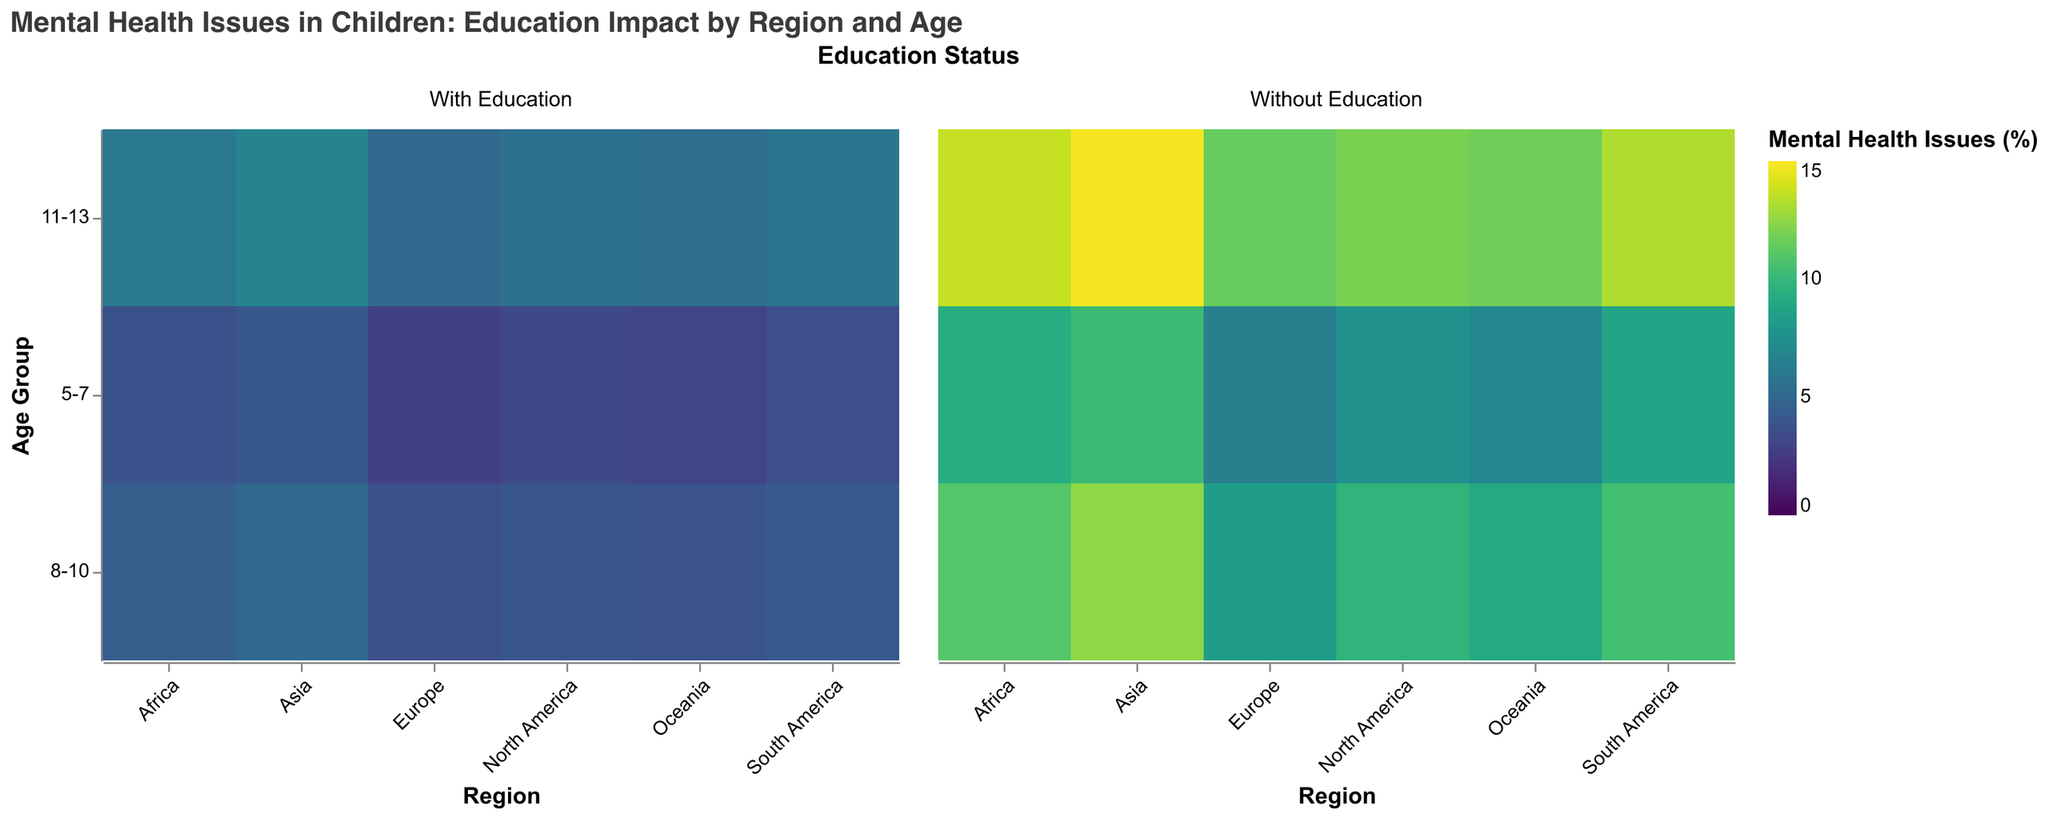What is the title of the heatmap? The title of the heatmap is specified at the top of the figure.
Answer: Mental Health Issues in Children: Education Impact by Region and Age Which region has the highest percentage of mental health issues in children without education in the 11-13 age group? Look at the cells corresponding to the 11-13 age group in the "Without Education" facet and identify the highest value for mental health issues within that group.
Answer: Asia What is the difference in the percentage of mental health issues between children with and without education in Europe for the 8-10 age group? Subtract the value of mental health issues with education from the value without education for the 8-10 age group in the Europe region.
Answer: 4.7% How does the percentage of mental health issues in children with education in the 5-7 age group in North America compare to Oceania? Compare the values for the 5-7 age group in North America and Oceania in the "With Education" facet.
Answer: North America has a higher percentage Which age group shows the smallest difference in mental health issues percentages between children with and without education in Africa? Calculate the differences for each age group in Africa and find the smallest difference.
Answer: 5-7 In which region and age group is the percentage of mental health issues greatest without education, and how much is it? Identify the highest value in the "Without Education" facet and note the corresponding region and age group.
Answer: Asia, 11-13, 14.8% What is the average percentage of mental health issues in children with education across all regions for the 8-10 age group? Sum up the percentages for 8-10 age group in all regions in the "With Education" facet and divide by the number of regions.
Answer: 4.2% In which region in the 11-13 age group do children with education have the lowest percentage of mental health issues? Look at the cells corresponding to the 11-13 age group in the "With Education" facet and identify the lowest value.
Answer: Europe How does the impact of education on mental health issues change as children age in South America? Compare the percentage difference between with and without education for each age group in South America to see the trend.
Answer: The impact increases with age Which age group in Oceania shows the largest improvement (reduction) in mental health issues with education compared to without? Subtract the "With Education" percentages from "Without Education" percentages for each age group in Oceania and identify the largest value to denote improvement.
Answer: 5-7 